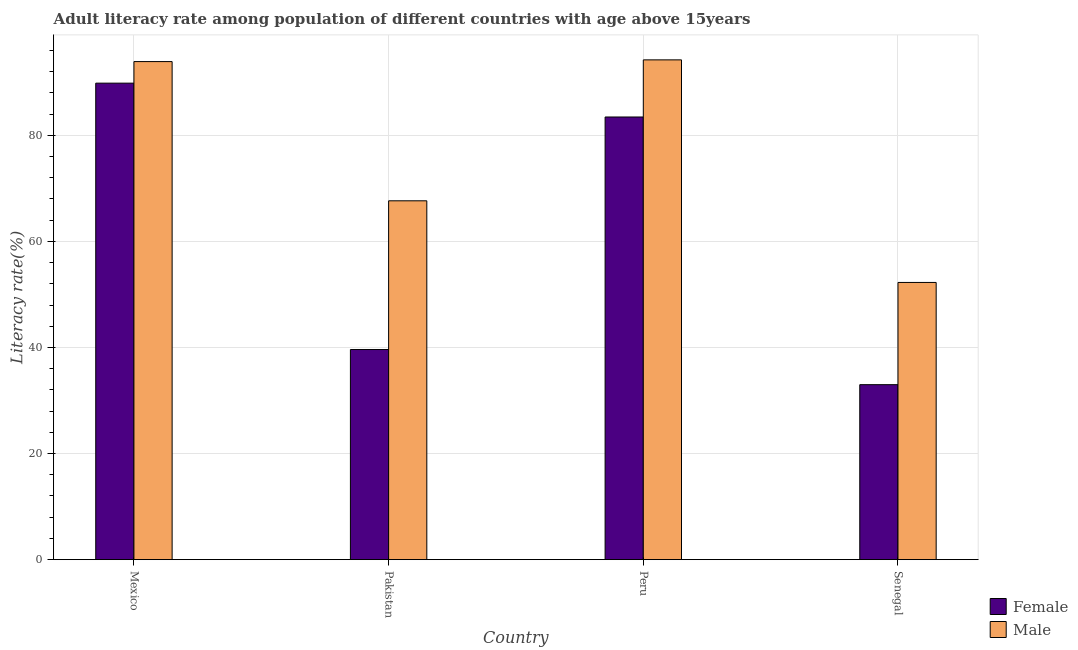How many groups of bars are there?
Make the answer very short. 4. Are the number of bars on each tick of the X-axis equal?
Provide a short and direct response. Yes. How many bars are there on the 4th tick from the left?
Ensure brevity in your answer.  2. How many bars are there on the 3rd tick from the right?
Provide a succinct answer. 2. In how many cases, is the number of bars for a given country not equal to the number of legend labels?
Make the answer very short. 0. What is the male adult literacy rate in Peru?
Offer a terse response. 94.23. Across all countries, what is the maximum male adult literacy rate?
Give a very brief answer. 94.23. Across all countries, what is the minimum male adult literacy rate?
Your answer should be very brief. 52.26. In which country was the female adult literacy rate maximum?
Keep it short and to the point. Mexico. In which country was the female adult literacy rate minimum?
Ensure brevity in your answer.  Senegal. What is the total female adult literacy rate in the graph?
Give a very brief answer. 245.89. What is the difference between the male adult literacy rate in Pakistan and that in Senegal?
Offer a very short reply. 15.39. What is the difference between the female adult literacy rate in Mexico and the male adult literacy rate in Pakistan?
Offer a very short reply. 22.18. What is the average female adult literacy rate per country?
Offer a very short reply. 61.47. What is the difference between the male adult literacy rate and female adult literacy rate in Pakistan?
Offer a very short reply. 28.04. In how many countries, is the male adult literacy rate greater than 20 %?
Your response must be concise. 4. What is the ratio of the male adult literacy rate in Mexico to that in Peru?
Keep it short and to the point. 1. Is the difference between the female adult literacy rate in Peru and Senegal greater than the difference between the male adult literacy rate in Peru and Senegal?
Your answer should be very brief. Yes. What is the difference between the highest and the second highest female adult literacy rate?
Provide a succinct answer. 6.38. What is the difference between the highest and the lowest male adult literacy rate?
Make the answer very short. 41.97. Is the sum of the male adult literacy rate in Mexico and Peru greater than the maximum female adult literacy rate across all countries?
Your answer should be very brief. Yes. What does the 1st bar from the left in Mexico represents?
Offer a terse response. Female. How many bars are there?
Provide a short and direct response. 8. How many countries are there in the graph?
Keep it short and to the point. 4. Are the values on the major ticks of Y-axis written in scientific E-notation?
Your answer should be compact. No. Does the graph contain grids?
Your answer should be compact. Yes. How are the legend labels stacked?
Make the answer very short. Vertical. What is the title of the graph?
Your answer should be compact. Adult literacy rate among population of different countries with age above 15years. What is the label or title of the Y-axis?
Ensure brevity in your answer.  Literacy rate(%). What is the Literacy rate(%) in Female in Mexico?
Make the answer very short. 89.83. What is the Literacy rate(%) of Male in Mexico?
Give a very brief answer. 93.9. What is the Literacy rate(%) of Female in Pakistan?
Your answer should be very brief. 39.61. What is the Literacy rate(%) in Male in Pakistan?
Provide a short and direct response. 67.65. What is the Literacy rate(%) in Female in Peru?
Your answer should be compact. 83.45. What is the Literacy rate(%) of Male in Peru?
Your answer should be compact. 94.23. What is the Literacy rate(%) in Female in Senegal?
Your answer should be compact. 32.99. What is the Literacy rate(%) in Male in Senegal?
Keep it short and to the point. 52.26. Across all countries, what is the maximum Literacy rate(%) of Female?
Your answer should be compact. 89.83. Across all countries, what is the maximum Literacy rate(%) in Male?
Give a very brief answer. 94.23. Across all countries, what is the minimum Literacy rate(%) of Female?
Offer a very short reply. 32.99. Across all countries, what is the minimum Literacy rate(%) of Male?
Your answer should be very brief. 52.26. What is the total Literacy rate(%) of Female in the graph?
Make the answer very short. 245.89. What is the total Literacy rate(%) in Male in the graph?
Make the answer very short. 308.04. What is the difference between the Literacy rate(%) of Female in Mexico and that in Pakistan?
Provide a short and direct response. 50.22. What is the difference between the Literacy rate(%) of Male in Mexico and that in Pakistan?
Ensure brevity in your answer.  26.25. What is the difference between the Literacy rate(%) of Female in Mexico and that in Peru?
Your answer should be very brief. 6.38. What is the difference between the Literacy rate(%) in Male in Mexico and that in Peru?
Your answer should be very brief. -0.32. What is the difference between the Literacy rate(%) in Female in Mexico and that in Senegal?
Provide a succinct answer. 56.85. What is the difference between the Literacy rate(%) in Male in Mexico and that in Senegal?
Keep it short and to the point. 41.64. What is the difference between the Literacy rate(%) of Female in Pakistan and that in Peru?
Make the answer very short. -43.84. What is the difference between the Literacy rate(%) of Male in Pakistan and that in Peru?
Make the answer very short. -26.57. What is the difference between the Literacy rate(%) in Female in Pakistan and that in Senegal?
Keep it short and to the point. 6.63. What is the difference between the Literacy rate(%) of Male in Pakistan and that in Senegal?
Ensure brevity in your answer.  15.39. What is the difference between the Literacy rate(%) in Female in Peru and that in Senegal?
Offer a terse response. 50.47. What is the difference between the Literacy rate(%) of Male in Peru and that in Senegal?
Your answer should be very brief. 41.97. What is the difference between the Literacy rate(%) of Female in Mexico and the Literacy rate(%) of Male in Pakistan?
Provide a succinct answer. 22.18. What is the difference between the Literacy rate(%) in Female in Mexico and the Literacy rate(%) in Male in Peru?
Provide a short and direct response. -4.39. What is the difference between the Literacy rate(%) in Female in Mexico and the Literacy rate(%) in Male in Senegal?
Provide a short and direct response. 37.58. What is the difference between the Literacy rate(%) in Female in Pakistan and the Literacy rate(%) in Male in Peru?
Provide a short and direct response. -54.61. What is the difference between the Literacy rate(%) in Female in Pakistan and the Literacy rate(%) in Male in Senegal?
Provide a short and direct response. -12.65. What is the difference between the Literacy rate(%) in Female in Peru and the Literacy rate(%) in Male in Senegal?
Offer a terse response. 31.2. What is the average Literacy rate(%) in Female per country?
Offer a very short reply. 61.47. What is the average Literacy rate(%) of Male per country?
Give a very brief answer. 77.01. What is the difference between the Literacy rate(%) in Female and Literacy rate(%) in Male in Mexico?
Your response must be concise. -4.07. What is the difference between the Literacy rate(%) in Female and Literacy rate(%) in Male in Pakistan?
Your response must be concise. -28.04. What is the difference between the Literacy rate(%) in Female and Literacy rate(%) in Male in Peru?
Your answer should be compact. -10.77. What is the difference between the Literacy rate(%) in Female and Literacy rate(%) in Male in Senegal?
Provide a succinct answer. -19.27. What is the ratio of the Literacy rate(%) of Female in Mexico to that in Pakistan?
Provide a succinct answer. 2.27. What is the ratio of the Literacy rate(%) of Male in Mexico to that in Pakistan?
Keep it short and to the point. 1.39. What is the ratio of the Literacy rate(%) of Female in Mexico to that in Peru?
Your answer should be very brief. 1.08. What is the ratio of the Literacy rate(%) of Male in Mexico to that in Peru?
Provide a succinct answer. 1. What is the ratio of the Literacy rate(%) in Female in Mexico to that in Senegal?
Ensure brevity in your answer.  2.72. What is the ratio of the Literacy rate(%) in Male in Mexico to that in Senegal?
Provide a succinct answer. 1.8. What is the ratio of the Literacy rate(%) of Female in Pakistan to that in Peru?
Your response must be concise. 0.47. What is the ratio of the Literacy rate(%) of Male in Pakistan to that in Peru?
Offer a terse response. 0.72. What is the ratio of the Literacy rate(%) in Female in Pakistan to that in Senegal?
Provide a succinct answer. 1.2. What is the ratio of the Literacy rate(%) of Male in Pakistan to that in Senegal?
Provide a succinct answer. 1.29. What is the ratio of the Literacy rate(%) in Female in Peru to that in Senegal?
Provide a short and direct response. 2.53. What is the ratio of the Literacy rate(%) in Male in Peru to that in Senegal?
Provide a succinct answer. 1.8. What is the difference between the highest and the second highest Literacy rate(%) of Female?
Your answer should be compact. 6.38. What is the difference between the highest and the second highest Literacy rate(%) in Male?
Your answer should be very brief. 0.32. What is the difference between the highest and the lowest Literacy rate(%) in Female?
Your answer should be compact. 56.85. What is the difference between the highest and the lowest Literacy rate(%) of Male?
Provide a short and direct response. 41.97. 